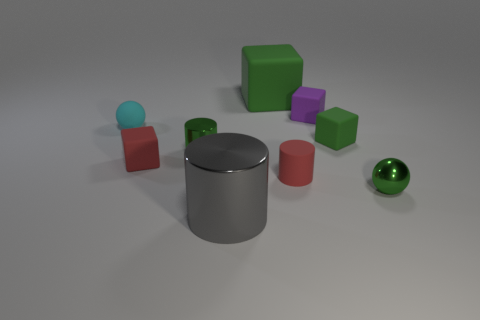Subtract 1 cubes. How many cubes are left? 3 Subtract all blue blocks. Subtract all green cylinders. How many blocks are left? 4 Add 1 cylinders. How many objects exist? 10 Subtract all cylinders. How many objects are left? 6 Subtract all metallic cylinders. Subtract all red objects. How many objects are left? 5 Add 4 tiny cyan rubber things. How many tiny cyan rubber things are left? 5 Add 2 tiny yellow objects. How many tiny yellow objects exist? 2 Subtract 0 brown blocks. How many objects are left? 9 